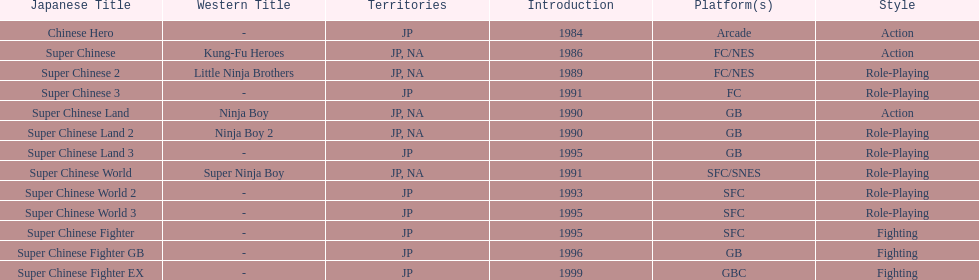Of the titles released in north america, which had the least releases? Super Chinese World. 